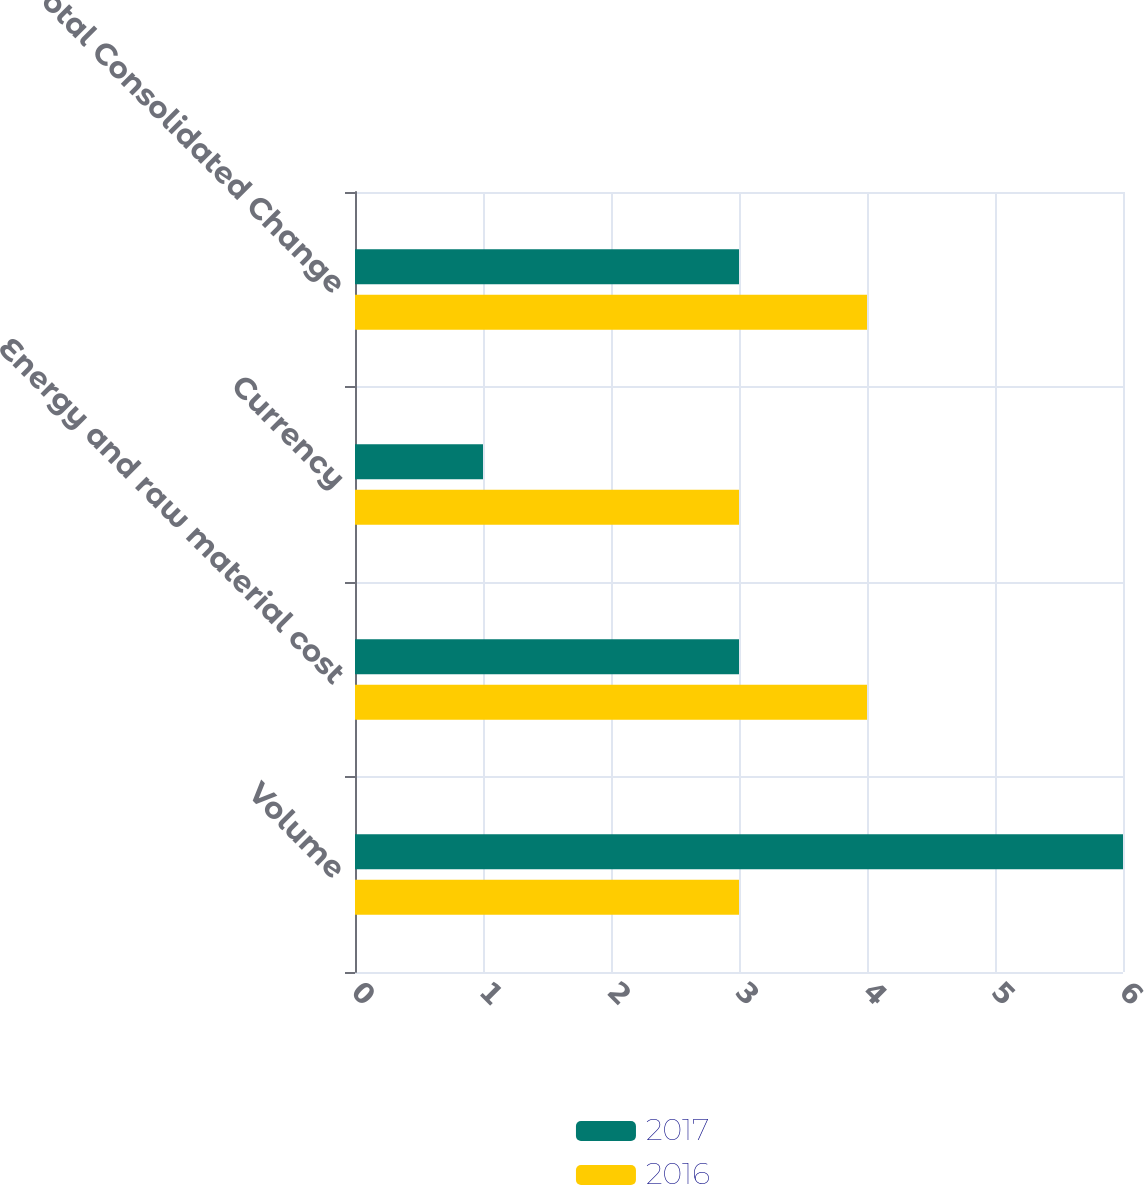Convert chart to OTSL. <chart><loc_0><loc_0><loc_500><loc_500><stacked_bar_chart><ecel><fcel>Volume<fcel>Energy and raw material cost<fcel>Currency<fcel>Total Consolidated Change<nl><fcel>2017<fcel>6<fcel>3<fcel>1<fcel>3<nl><fcel>2016<fcel>3<fcel>4<fcel>3<fcel>4<nl></chart> 